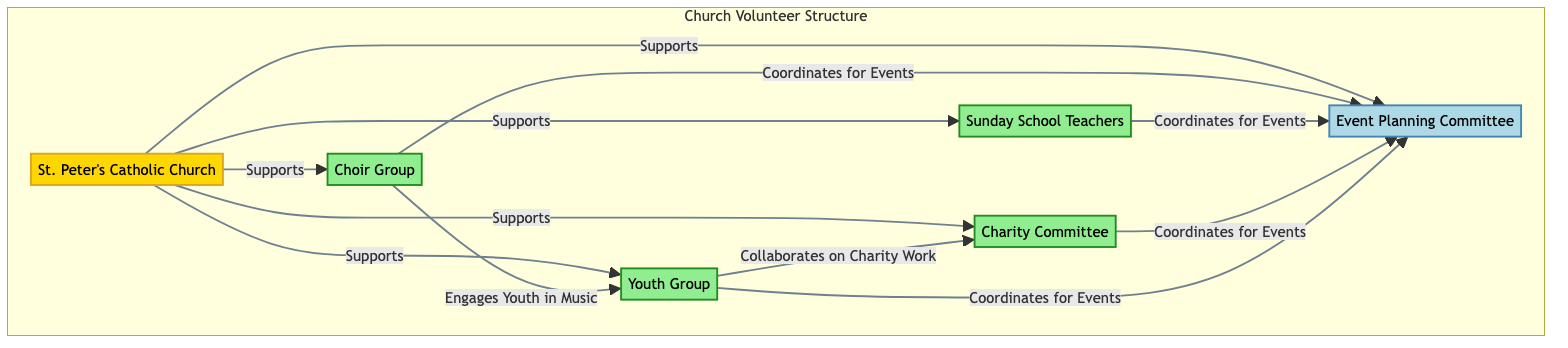What is the main node representing the church in the diagram? The main node representing the church is labeled "St. Peter's Catholic Church". This is identified as the central node connected to other volunteer groups and committees to show its supportive role.
Answer: St. Peter's Catholic Church How many volunteer groups are represented in the diagram? There are five volunteer groups identified in the diagram: Choir Group, Sunday School Teachers, Charity Committee, Event Planning Committee, and Youth Group. Counting each of these nodes provides the total.
Answer: 5 Which group collaborates on charity work? The node representing the Youth Group shows a direct connection to the Charity Committee with the label "Collaborates on Charity Work". This indicates the link between these two entities.
Answer: Youth Group What relationship does the Choir Group have with the Event Planning Committee? The relationship between the Choir Group and the Event Planning Committee is labeled "Coordinates for Events". This specifies how the Choir interacts with the Event Committee.
Answer: Coordinates for Events Which group engages youth in music? The diagram indicates that the Choir Group engages youth in music, as shown by the edge labeled "Engages Youth in Music" connecting Choir and Youth Group.
Answer: Engages Youth in Music What type of relationship does the Church have with each of the volunteer groups? The relationship between the Church and each of the volunteer groups is categorized as "Supports". This is consistently labeled across all connections from the Church to the groups.
Answer: Supports Which two groups share a coordination role in event planning? The groups that share a coordination role in event planning are the Choir Group, Sunday School Teachers, Charity Committee, and Youth Group, all connecting to the Event Planning Committee. This indicates multiple collaborations in organizing events.
Answer: Choir Group and Sunday School Teachers How many edges connect the Youth Group to other nodes in the diagram? The Youth Group connects to three other nodes: Event Planning Committee (Coordinates for Events), Charity Committee (Collaborates on Charity Work), and Choir Group (Engages Youth in Music). Counting these edges gives the total connections for the Youth Group.
Answer: 3 